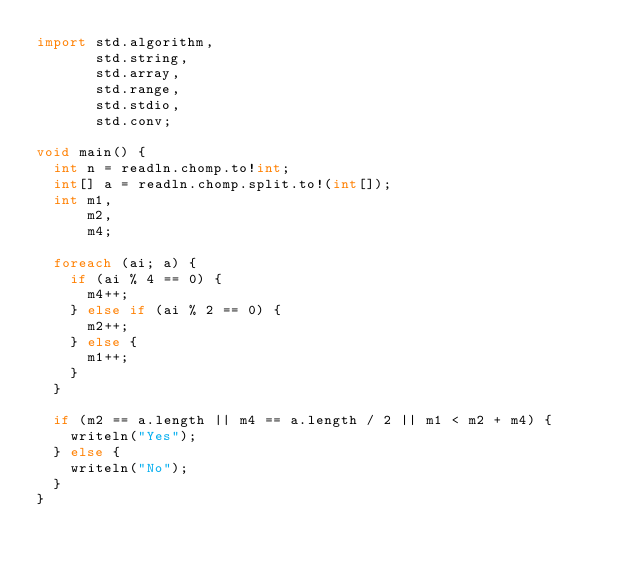<code> <loc_0><loc_0><loc_500><loc_500><_D_>import std.algorithm,
       std.string,
       std.array,
       std.range,
       std.stdio,
       std.conv;

void main() {
  int n = readln.chomp.to!int;
  int[] a = readln.chomp.split.to!(int[]);
  int m1,
      m2,
      m4;

  foreach (ai; a) {
    if (ai % 4 == 0) {
      m4++;
    } else if (ai % 2 == 0) {
      m2++;
    } else {
      m1++;
    }
  }

  if (m2 == a.length || m4 == a.length / 2 || m1 < m2 + m4) {
    writeln("Yes");
  } else {
    writeln("No");
  }
}
</code> 